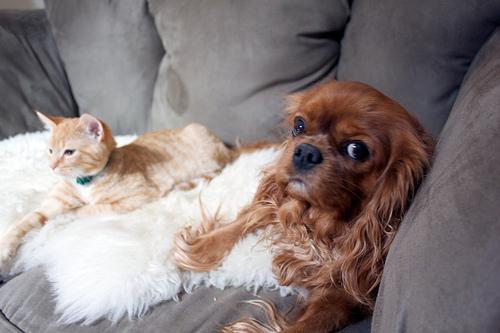Are the two animals friendly?
Be succinct. Yes. What is the cat sitting on?
Quick response, please. Dog. How many animals are here?
Give a very brief answer. 2. 